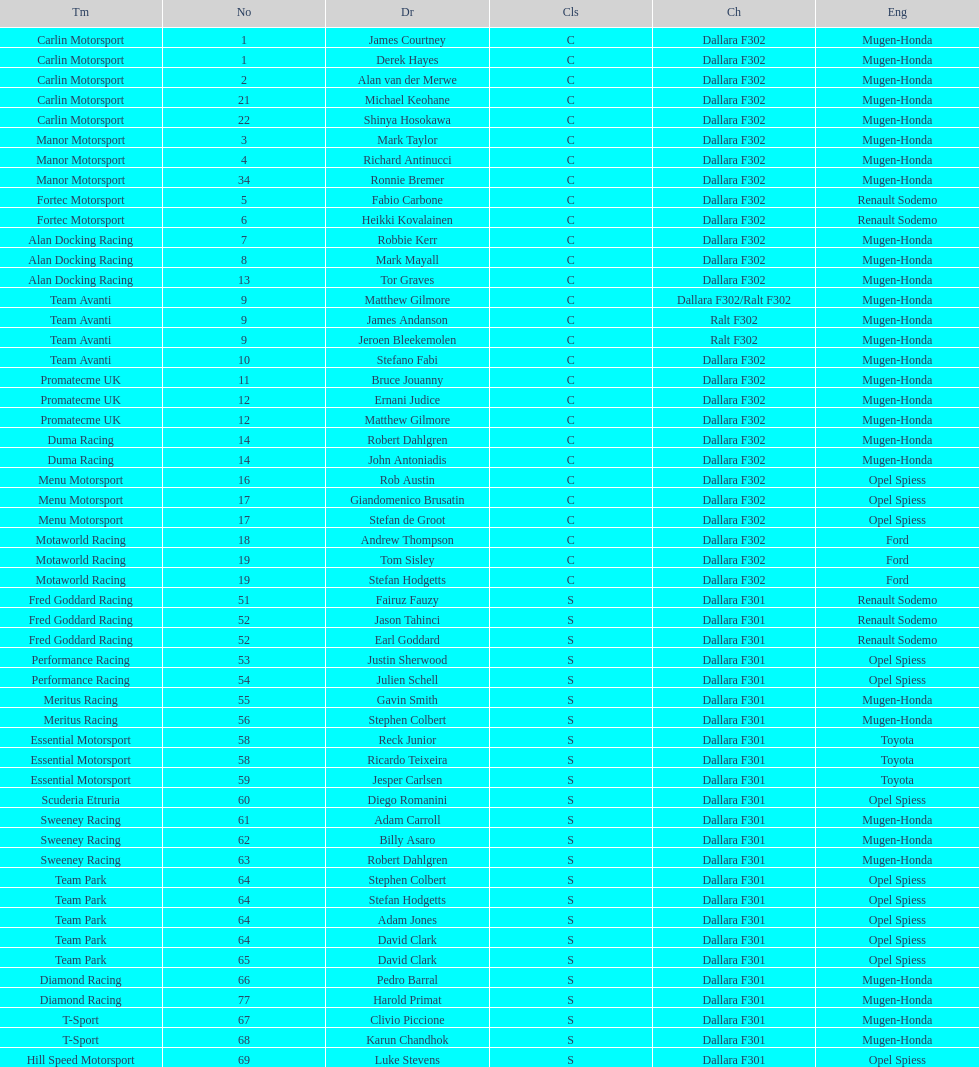Parse the full table. {'header': ['Tm', 'No', 'Dr', 'Cls', 'Ch', 'Eng'], 'rows': [['Carlin Motorsport', '1', 'James Courtney', 'C', 'Dallara F302', 'Mugen-Honda'], ['Carlin Motorsport', '1', 'Derek Hayes', 'C', 'Dallara F302', 'Mugen-Honda'], ['Carlin Motorsport', '2', 'Alan van der Merwe', 'C', 'Dallara F302', 'Mugen-Honda'], ['Carlin Motorsport', '21', 'Michael Keohane', 'C', 'Dallara F302', 'Mugen-Honda'], ['Carlin Motorsport', '22', 'Shinya Hosokawa', 'C', 'Dallara F302', 'Mugen-Honda'], ['Manor Motorsport', '3', 'Mark Taylor', 'C', 'Dallara F302', 'Mugen-Honda'], ['Manor Motorsport', '4', 'Richard Antinucci', 'C', 'Dallara F302', 'Mugen-Honda'], ['Manor Motorsport', '34', 'Ronnie Bremer', 'C', 'Dallara F302', 'Mugen-Honda'], ['Fortec Motorsport', '5', 'Fabio Carbone', 'C', 'Dallara F302', 'Renault Sodemo'], ['Fortec Motorsport', '6', 'Heikki Kovalainen', 'C', 'Dallara F302', 'Renault Sodemo'], ['Alan Docking Racing', '7', 'Robbie Kerr', 'C', 'Dallara F302', 'Mugen-Honda'], ['Alan Docking Racing', '8', 'Mark Mayall', 'C', 'Dallara F302', 'Mugen-Honda'], ['Alan Docking Racing', '13', 'Tor Graves', 'C', 'Dallara F302', 'Mugen-Honda'], ['Team Avanti', '9', 'Matthew Gilmore', 'C', 'Dallara F302/Ralt F302', 'Mugen-Honda'], ['Team Avanti', '9', 'James Andanson', 'C', 'Ralt F302', 'Mugen-Honda'], ['Team Avanti', '9', 'Jeroen Bleekemolen', 'C', 'Ralt F302', 'Mugen-Honda'], ['Team Avanti', '10', 'Stefano Fabi', 'C', 'Dallara F302', 'Mugen-Honda'], ['Promatecme UK', '11', 'Bruce Jouanny', 'C', 'Dallara F302', 'Mugen-Honda'], ['Promatecme UK', '12', 'Ernani Judice', 'C', 'Dallara F302', 'Mugen-Honda'], ['Promatecme UK', '12', 'Matthew Gilmore', 'C', 'Dallara F302', 'Mugen-Honda'], ['Duma Racing', '14', 'Robert Dahlgren', 'C', 'Dallara F302', 'Mugen-Honda'], ['Duma Racing', '14', 'John Antoniadis', 'C', 'Dallara F302', 'Mugen-Honda'], ['Menu Motorsport', '16', 'Rob Austin', 'C', 'Dallara F302', 'Opel Spiess'], ['Menu Motorsport', '17', 'Giandomenico Brusatin', 'C', 'Dallara F302', 'Opel Spiess'], ['Menu Motorsport', '17', 'Stefan de Groot', 'C', 'Dallara F302', 'Opel Spiess'], ['Motaworld Racing', '18', 'Andrew Thompson', 'C', 'Dallara F302', 'Ford'], ['Motaworld Racing', '19', 'Tom Sisley', 'C', 'Dallara F302', 'Ford'], ['Motaworld Racing', '19', 'Stefan Hodgetts', 'C', 'Dallara F302', 'Ford'], ['Fred Goddard Racing', '51', 'Fairuz Fauzy', 'S', 'Dallara F301', 'Renault Sodemo'], ['Fred Goddard Racing', '52', 'Jason Tahinci', 'S', 'Dallara F301', 'Renault Sodemo'], ['Fred Goddard Racing', '52', 'Earl Goddard', 'S', 'Dallara F301', 'Renault Sodemo'], ['Performance Racing', '53', 'Justin Sherwood', 'S', 'Dallara F301', 'Opel Spiess'], ['Performance Racing', '54', 'Julien Schell', 'S', 'Dallara F301', 'Opel Spiess'], ['Meritus Racing', '55', 'Gavin Smith', 'S', 'Dallara F301', 'Mugen-Honda'], ['Meritus Racing', '56', 'Stephen Colbert', 'S', 'Dallara F301', 'Mugen-Honda'], ['Essential Motorsport', '58', 'Reck Junior', 'S', 'Dallara F301', 'Toyota'], ['Essential Motorsport', '58', 'Ricardo Teixeira', 'S', 'Dallara F301', 'Toyota'], ['Essential Motorsport', '59', 'Jesper Carlsen', 'S', 'Dallara F301', 'Toyota'], ['Scuderia Etruria', '60', 'Diego Romanini', 'S', 'Dallara F301', 'Opel Spiess'], ['Sweeney Racing', '61', 'Adam Carroll', 'S', 'Dallara F301', 'Mugen-Honda'], ['Sweeney Racing', '62', 'Billy Asaro', 'S', 'Dallara F301', 'Mugen-Honda'], ['Sweeney Racing', '63', 'Robert Dahlgren', 'S', 'Dallara F301', 'Mugen-Honda'], ['Team Park', '64', 'Stephen Colbert', 'S', 'Dallara F301', 'Opel Spiess'], ['Team Park', '64', 'Stefan Hodgetts', 'S', 'Dallara F301', 'Opel Spiess'], ['Team Park', '64', 'Adam Jones', 'S', 'Dallara F301', 'Opel Spiess'], ['Team Park', '64', 'David Clark', 'S', 'Dallara F301', 'Opel Spiess'], ['Team Park', '65', 'David Clark', 'S', 'Dallara F301', 'Opel Spiess'], ['Diamond Racing', '66', 'Pedro Barral', 'S', 'Dallara F301', 'Mugen-Honda'], ['Diamond Racing', '77', 'Harold Primat', 'S', 'Dallara F301', 'Mugen-Honda'], ['T-Sport', '67', 'Clivio Piccione', 'S', 'Dallara F301', 'Mugen-Honda'], ['T-Sport', '68', 'Karun Chandhok', 'S', 'Dallara F301', 'Mugen-Honda'], ['Hill Speed Motorsport', '69', 'Luke Stevens', 'S', 'Dallara F301', 'Opel Spiess']]} Which engine was used the most by teams this season? Mugen-Honda. 